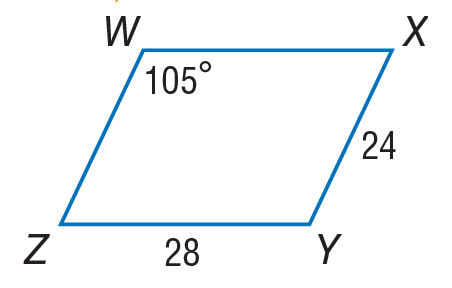Answer the mathemtical geometry problem and directly provide the correct option letter.
Question: Use parallelogram W X Y Z to find W Z.
Choices: A: 4 B: 24 C: 28 D: 52 B 